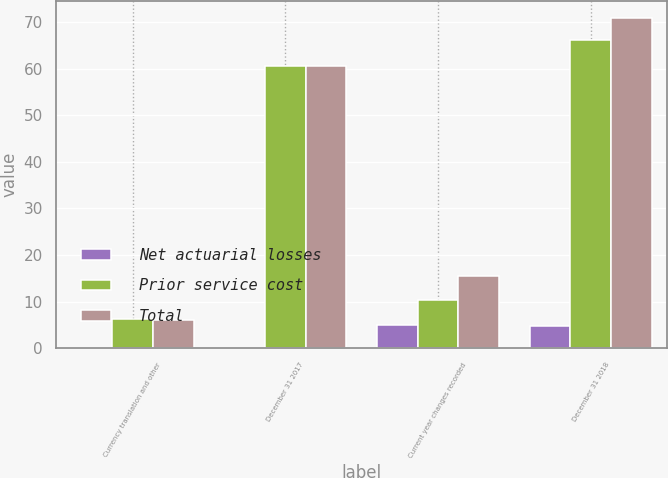Convert chart. <chart><loc_0><loc_0><loc_500><loc_500><stacked_bar_chart><ecel><fcel>Currency translation and other<fcel>December 31 2017<fcel>Current year changes recorded<fcel>December 31 2018<nl><fcel>Net actuarial losses<fcel>0.1<fcel>0.1<fcel>5<fcel>4.7<nl><fcel>Prior service cost<fcel>6.2<fcel>60.6<fcel>10.4<fcel>66.2<nl><fcel>Total<fcel>6.1<fcel>60.5<fcel>15.4<fcel>70.9<nl></chart> 